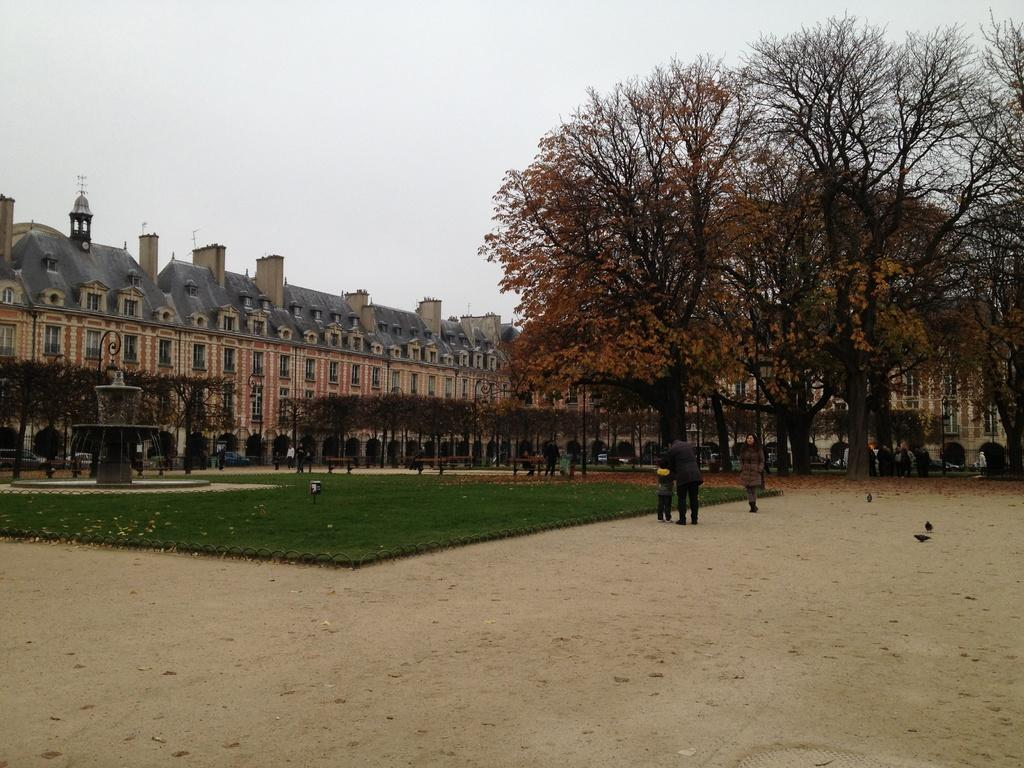What type of terrain is visible in the image? There is a land in the image. What is the ground surface like in the image? There is a grass surface in the image. What is a prominent feature in the image? There is a fountain in the image. What type of vegetation can be seen in the image? There are trees in the image. Are there any human figures in the image? Yes, there are people in the image. What can be seen in the background of the image? There is a building in the background of the image. What letter is being used to spell out the name of the fowl in the image? There is no fowl present in the image, and therefore no letter can be associated with it. 